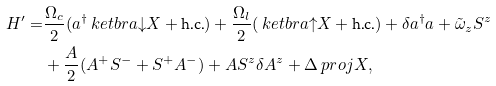<formula> <loc_0><loc_0><loc_500><loc_500>H ^ { \prime } = & \frac { \Omega _ { c } } { 2 } ( a ^ { \dagger } \ k e t b r a { \downarrow } { X } + \text {h.c.} ) + \frac { \Omega _ { l } } { 2 } ( \ k e t b r a { \uparrow } { X } + \text {h.c.} ) + \delta a ^ { \dagger } a + \tilde { \omega } _ { z } S ^ { z } \\ & + \frac { A } { 2 } ( A ^ { + } S ^ { - } + S ^ { + } A ^ { - } ) + A S ^ { z } \delta A ^ { z } + \Delta \ p r o j { X } ,</formula> 